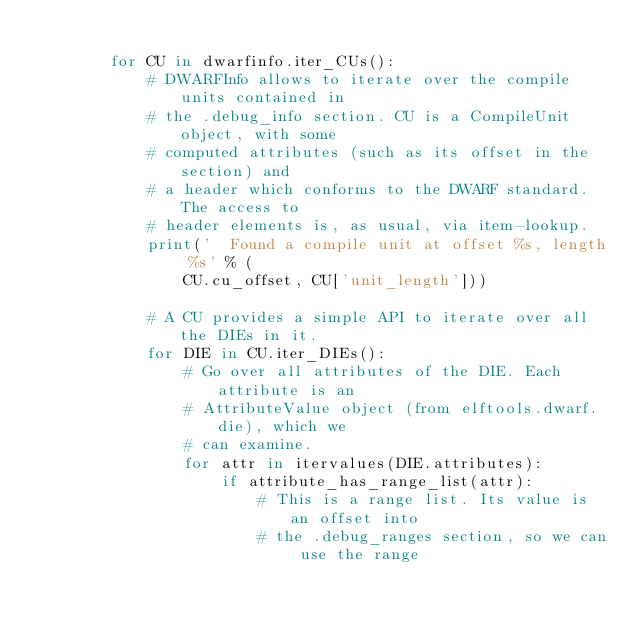<code> <loc_0><loc_0><loc_500><loc_500><_Python_>
        for CU in dwarfinfo.iter_CUs():
            # DWARFInfo allows to iterate over the compile units contained in
            # the .debug_info section. CU is a CompileUnit object, with some
            # computed attributes (such as its offset in the section) and
            # a header which conforms to the DWARF standard. The access to
            # header elements is, as usual, via item-lookup.
            print('  Found a compile unit at offset %s, length %s' % (
                CU.cu_offset, CU['unit_length']))

            # A CU provides a simple API to iterate over all the DIEs in it.
            for DIE in CU.iter_DIEs():
                # Go over all attributes of the DIE. Each attribute is an
                # AttributeValue object (from elftools.dwarf.die), which we
                # can examine.
                for attr in itervalues(DIE.attributes):
                    if attribute_has_range_list(attr):
                        # This is a range list. Its value is an offset into
                        # the .debug_ranges section, so we can use the range</code> 